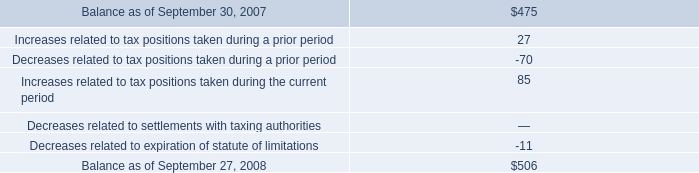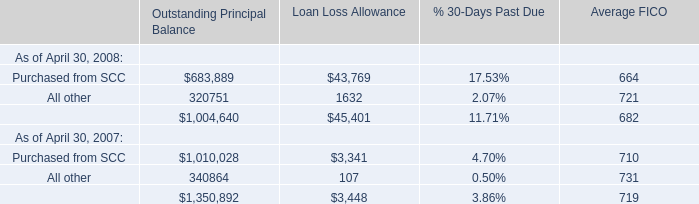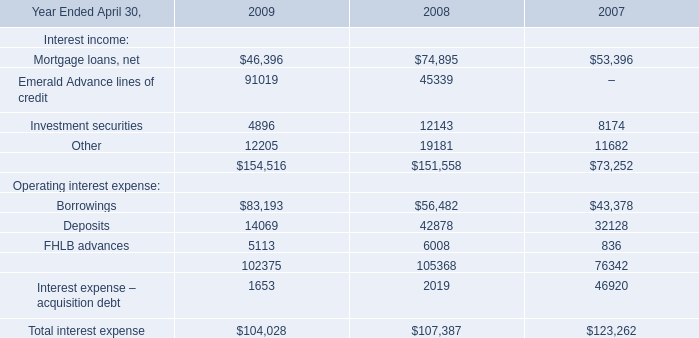what's the total amount of Mortgage loans, net of 2009, and All other of Outstanding Principal Balance ? 
Computations: (46396.0 + 320751.0)
Answer: 367147.0. 